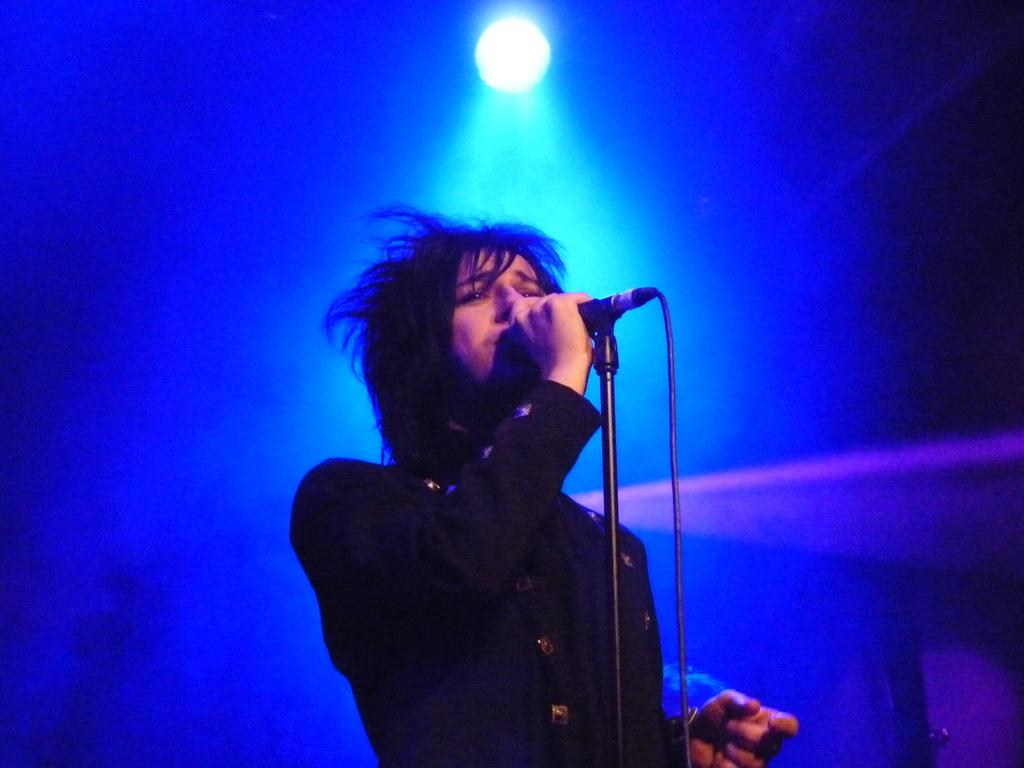What is the person in the image doing? The person is standing and holding a microphone. What can be seen behind the person in the image? There is a blue background in the image. What is used to illuminate the person in the image? Focusing light is present in the image. What type of pets can be seen playing in the afternoon in the image? There are no pets or any reference to an afternoon in the image. 